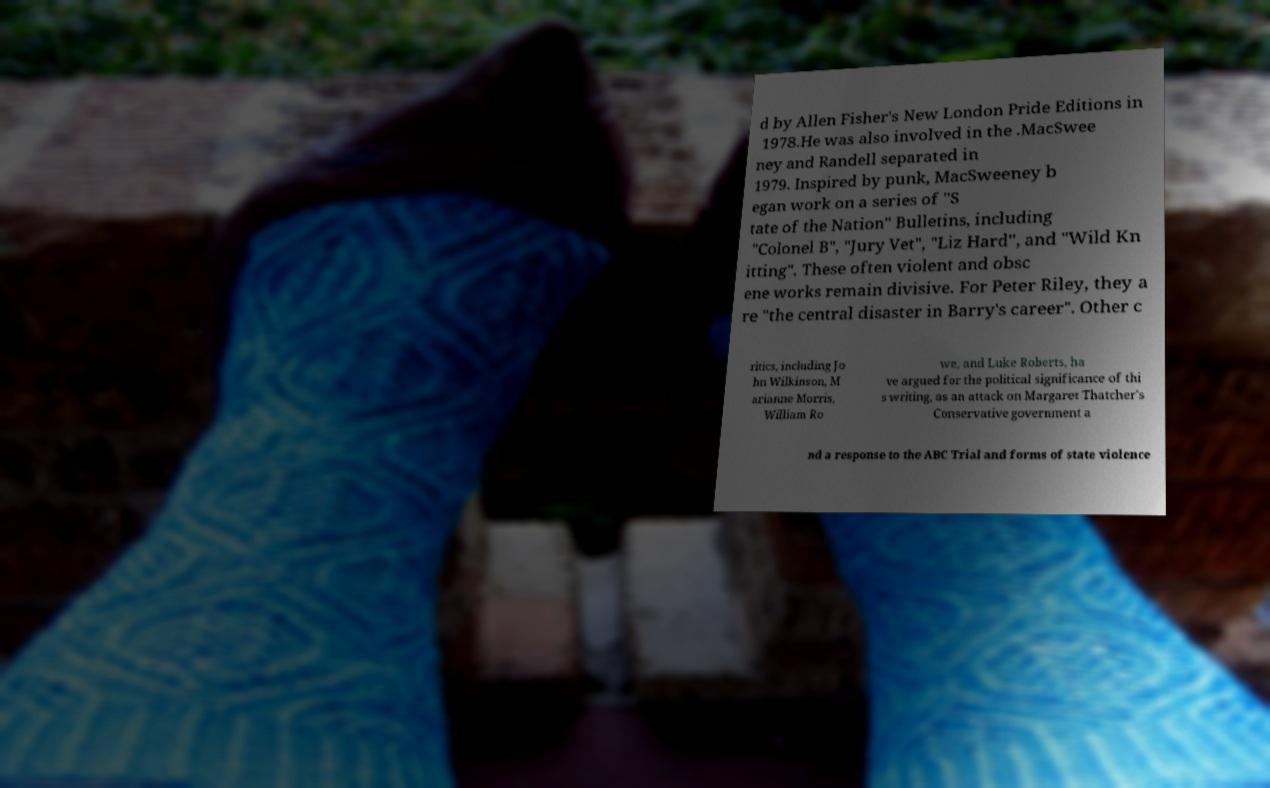Can you read and provide the text displayed in the image?This photo seems to have some interesting text. Can you extract and type it out for me? d by Allen Fisher's New London Pride Editions in 1978.He was also involved in the .MacSwee ney and Randell separated in 1979. Inspired by punk, MacSweeney b egan work on a series of "S tate of the Nation" Bulletins, including "Colonel B", "Jury Vet", "Liz Hard", and "Wild Kn itting". These often violent and obsc ene works remain divisive. For Peter Riley, they a re "the central disaster in Barry's career". Other c ritics, including Jo hn Wilkinson, M arianne Morris, William Ro we, and Luke Roberts, ha ve argued for the political significance of thi s writing, as an attack on Margaret Thatcher's Conservative government a nd a response to the ABC Trial and forms of state violence 